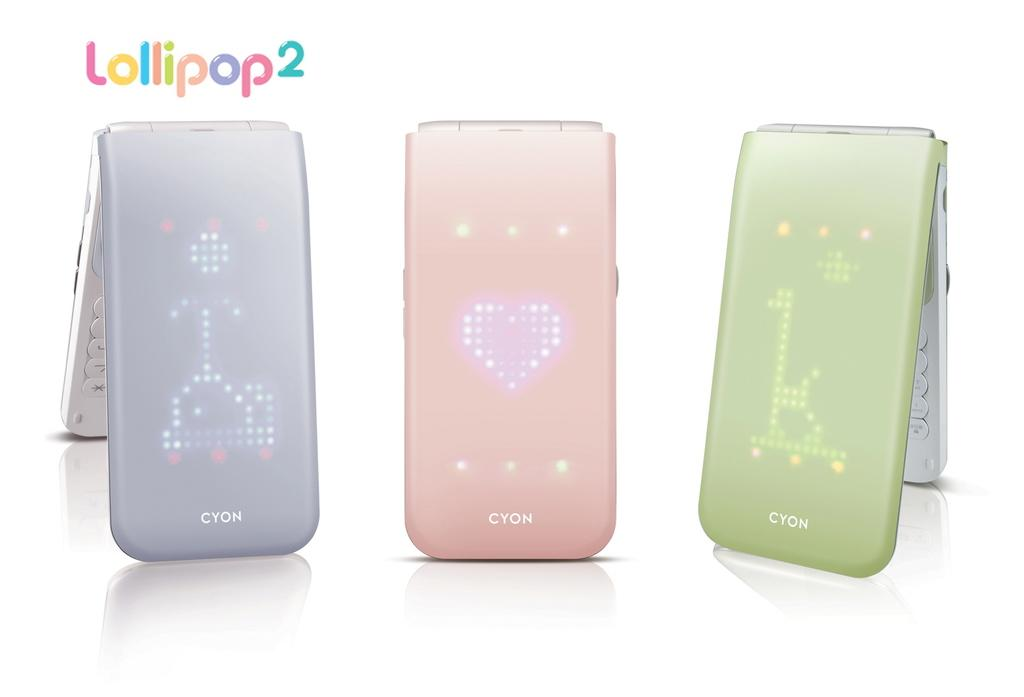<image>
Relay a brief, clear account of the picture shown. 3 Cyon's displayed in light blue, pink, and green. 